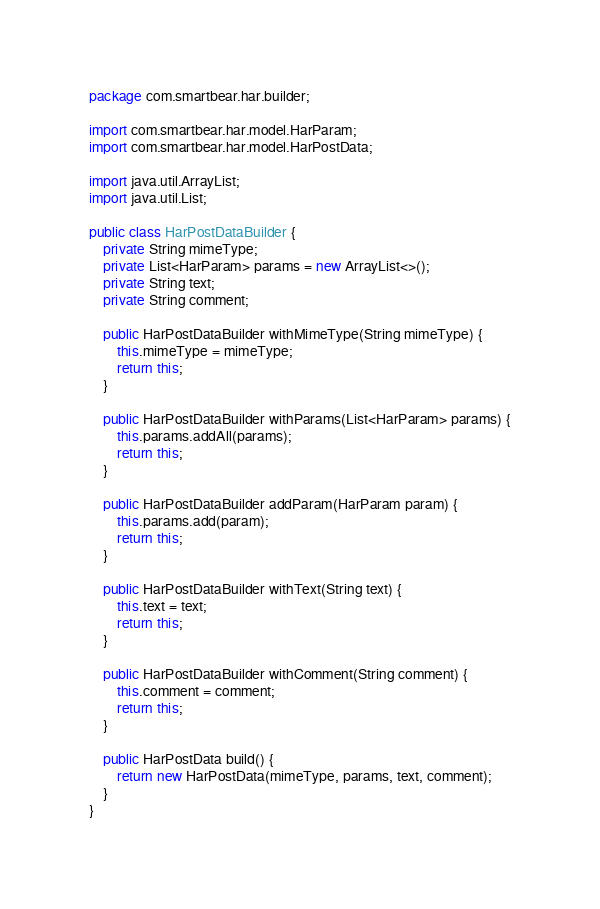<code> <loc_0><loc_0><loc_500><loc_500><_Java_>package com.smartbear.har.builder;

import com.smartbear.har.model.HarParam;
import com.smartbear.har.model.HarPostData;

import java.util.ArrayList;
import java.util.List;

public class HarPostDataBuilder {
    private String mimeType;
    private List<HarParam> params = new ArrayList<>();
    private String text;
    private String comment;

    public HarPostDataBuilder withMimeType(String mimeType) {
        this.mimeType = mimeType;
        return this;
    }

    public HarPostDataBuilder withParams(List<HarParam> params) {
        this.params.addAll(params);
        return this;
    }

    public HarPostDataBuilder addParam(HarParam param) {
        this.params.add(param);
        return this;
    }

    public HarPostDataBuilder withText(String text) {
        this.text = text;
        return this;
    }

    public HarPostDataBuilder withComment(String comment) {
        this.comment = comment;
        return this;
    }

    public HarPostData build() {
        return new HarPostData(mimeType, params, text, comment);
    }
}</code> 